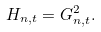Convert formula to latex. <formula><loc_0><loc_0><loc_500><loc_500>H _ { n , t } = G _ { n , t } ^ { 2 } .</formula> 